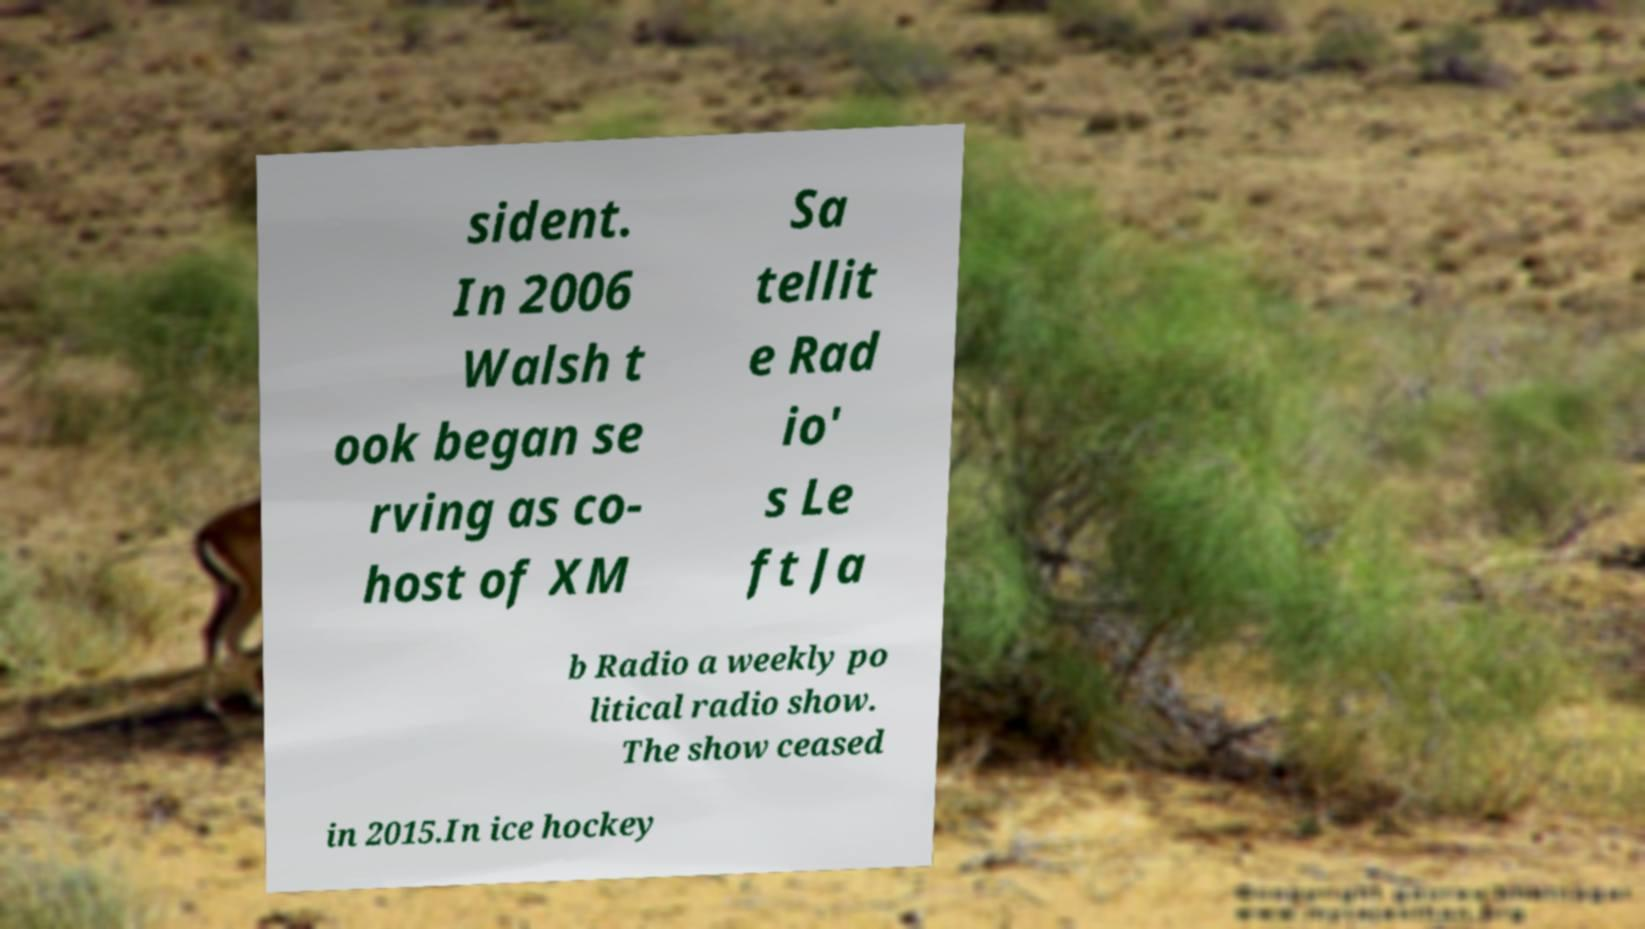Please read and relay the text visible in this image. What does it say? sident. In 2006 Walsh t ook began se rving as co- host of XM Sa tellit e Rad io' s Le ft Ja b Radio a weekly po litical radio show. The show ceased in 2015.In ice hockey 